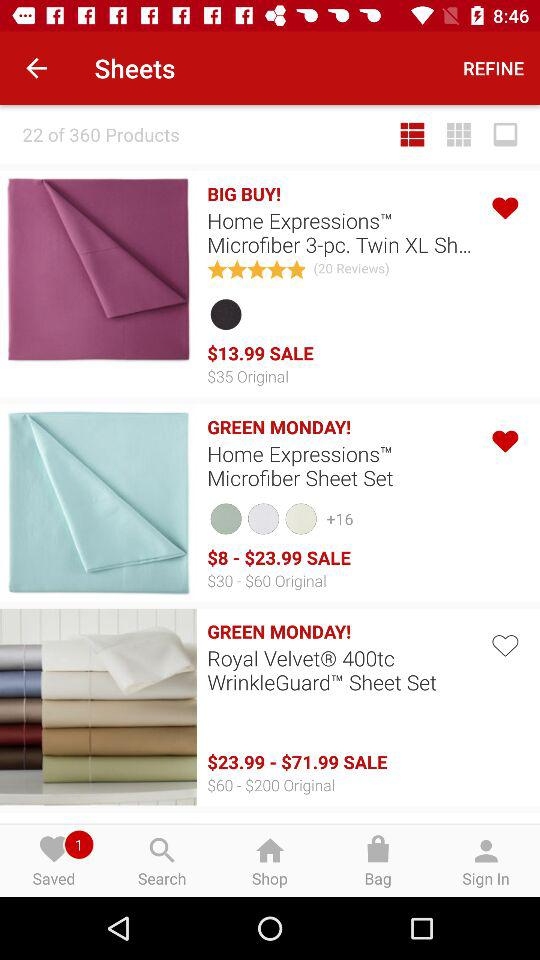What is the currency of price? The currency of price is dollars. 